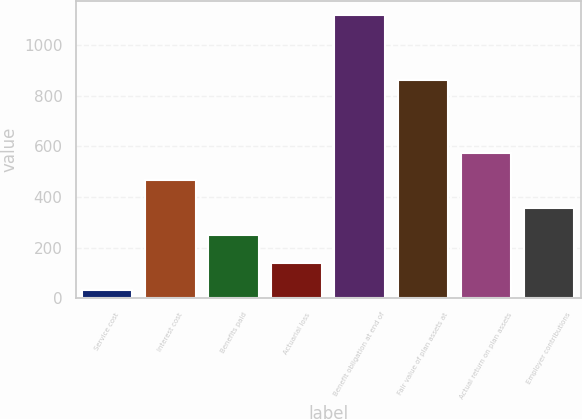Convert chart to OTSL. <chart><loc_0><loc_0><loc_500><loc_500><bar_chart><fcel>Service cost<fcel>Interest cost<fcel>Benefits paid<fcel>Actuarial loss<fcel>Benefit obligation at end of<fcel>Fair value of plan assets at<fcel>Actual return on plan assets<fcel>Employer contributions<nl><fcel>32<fcel>466.4<fcel>249.2<fcel>140.6<fcel>1118<fcel>860<fcel>575<fcel>357.8<nl></chart> 